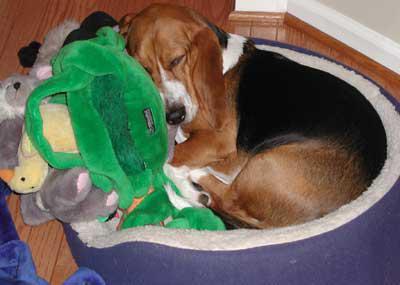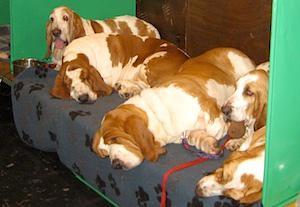The first image is the image on the left, the second image is the image on the right. For the images shown, is this caption "There are fewer than four hounds here." true? Answer yes or no. No. The first image is the image on the left, the second image is the image on the right. For the images displayed, is the sentence "At least one dog is resting its head." factually correct? Answer yes or no. Yes. 